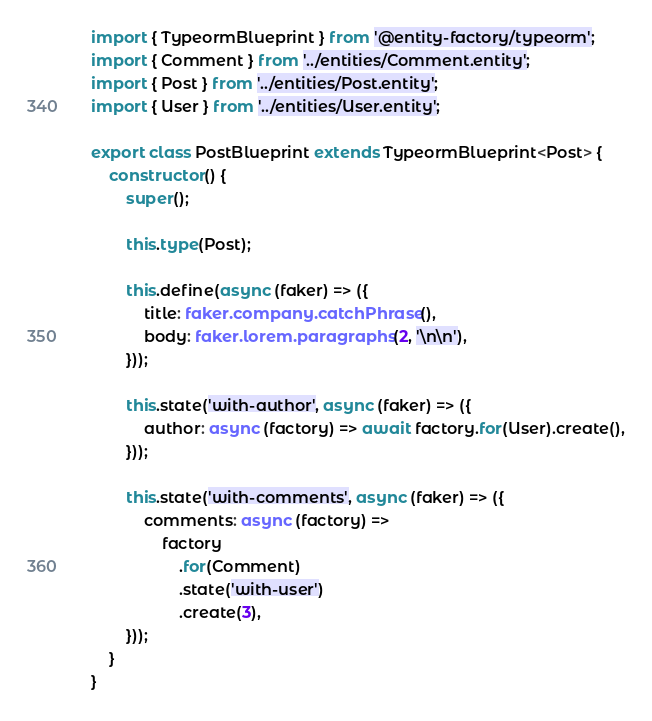<code> <loc_0><loc_0><loc_500><loc_500><_TypeScript_>import { TypeormBlueprint } from '@entity-factory/typeorm';
import { Comment } from '../entities/Comment.entity';
import { Post } from '../entities/Post.entity';
import { User } from '../entities/User.entity';

export class PostBlueprint extends TypeormBlueprint<Post> {
    constructor() {
        super();

        this.type(Post);

        this.define(async (faker) => ({
            title: faker.company.catchPhrase(),
            body: faker.lorem.paragraphs(2, '\n\n'),
        }));

        this.state('with-author', async (faker) => ({
            author: async (factory) => await factory.for(User).create(),
        }));

        this.state('with-comments', async (faker) => ({
            comments: async (factory) =>
                factory
                    .for(Comment)
                    .state('with-user')
                    .create(3),
        }));
    }
}
</code> 